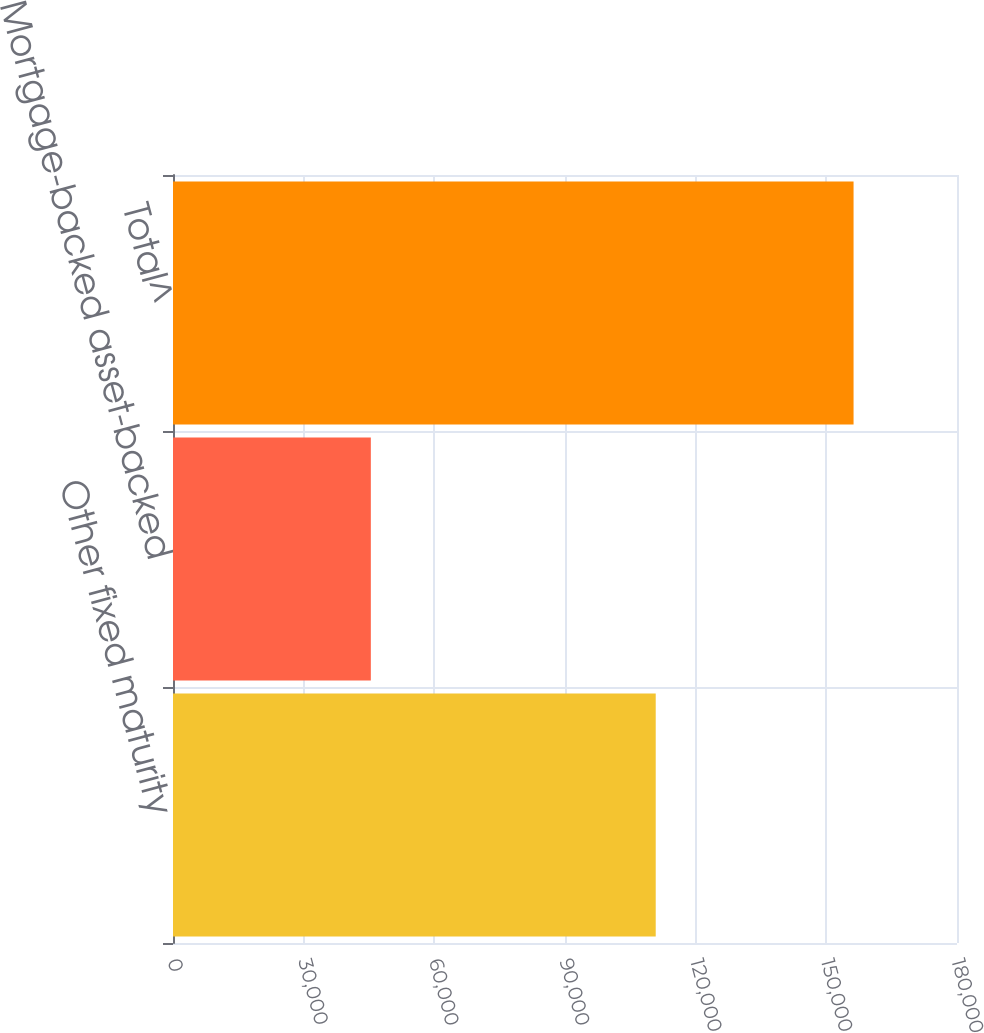Convert chart. <chart><loc_0><loc_0><loc_500><loc_500><bar_chart><fcel>Other fixed maturity<fcel>Mortgage-backed asset-backed<fcel>Total^<nl><fcel>110829<fcel>45422<fcel>156251<nl></chart> 